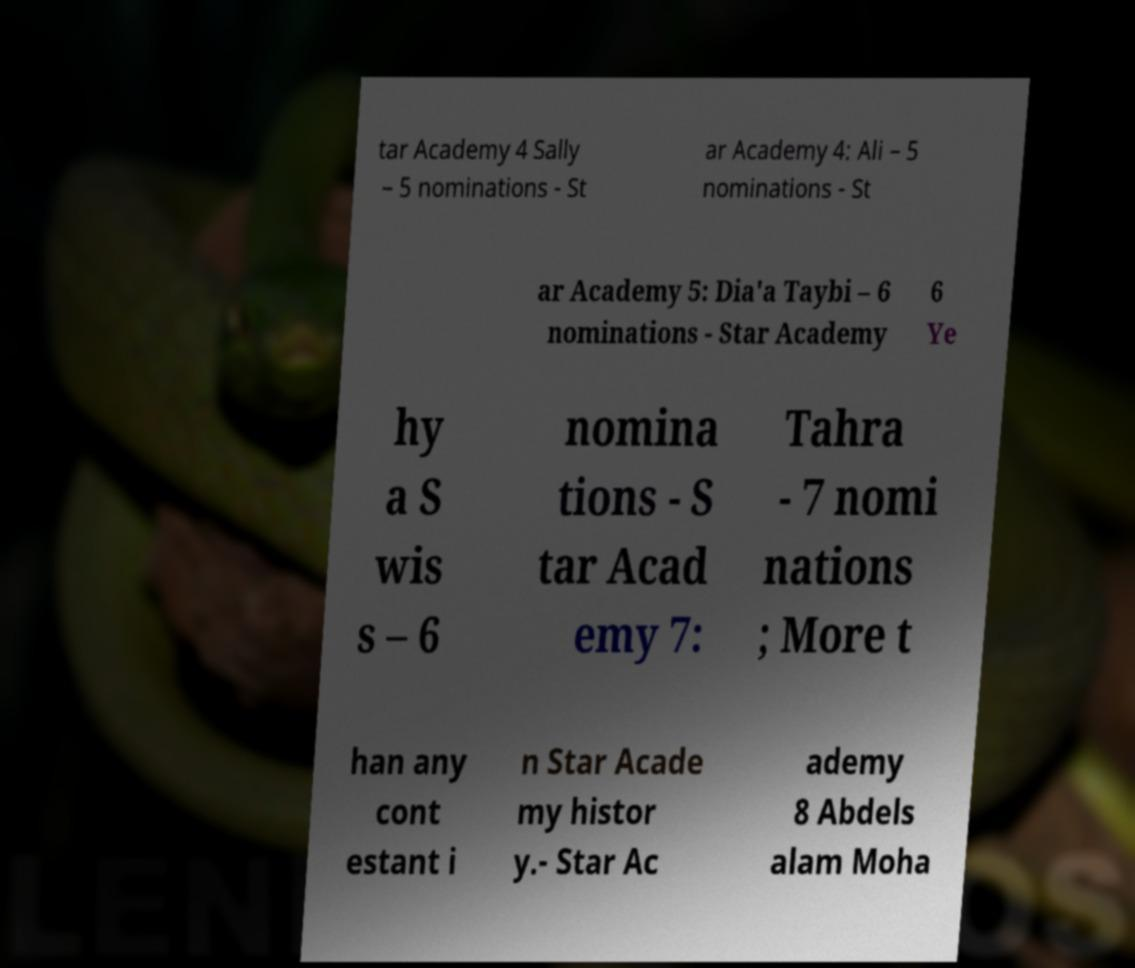Can you read and provide the text displayed in the image?This photo seems to have some interesting text. Can you extract and type it out for me? tar Academy 4 Sally – 5 nominations - St ar Academy 4: Ali – 5 nominations - St ar Academy 5: Dia'a Taybi – 6 nominations - Star Academy 6 Ye hy a S wis s – 6 nomina tions - S tar Acad emy 7: Tahra - 7 nomi nations ; More t han any cont estant i n Star Acade my histor y.- Star Ac ademy 8 Abdels alam Moha 